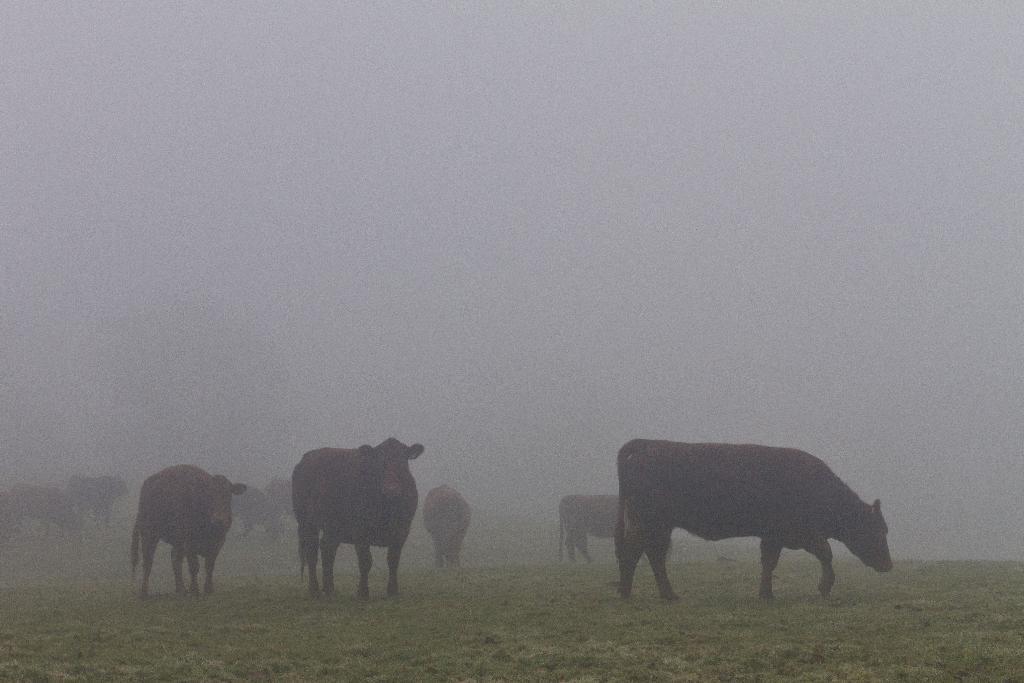Please provide a concise description of this image. In this image we can see a group of cows in the grass field. At the top of the image we can see the sky. 